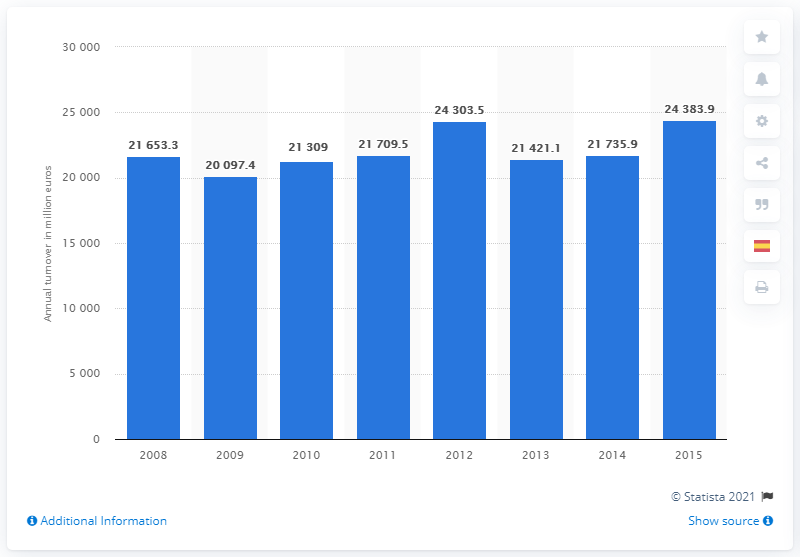Indicate a few pertinent items in this graphic. The turnover of Spain's real estate activities industry in 2015 was 24,383.9. 